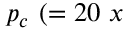<formula> <loc_0><loc_0><loc_500><loc_500>p _ { c } ( = 2 0 x \</formula> 